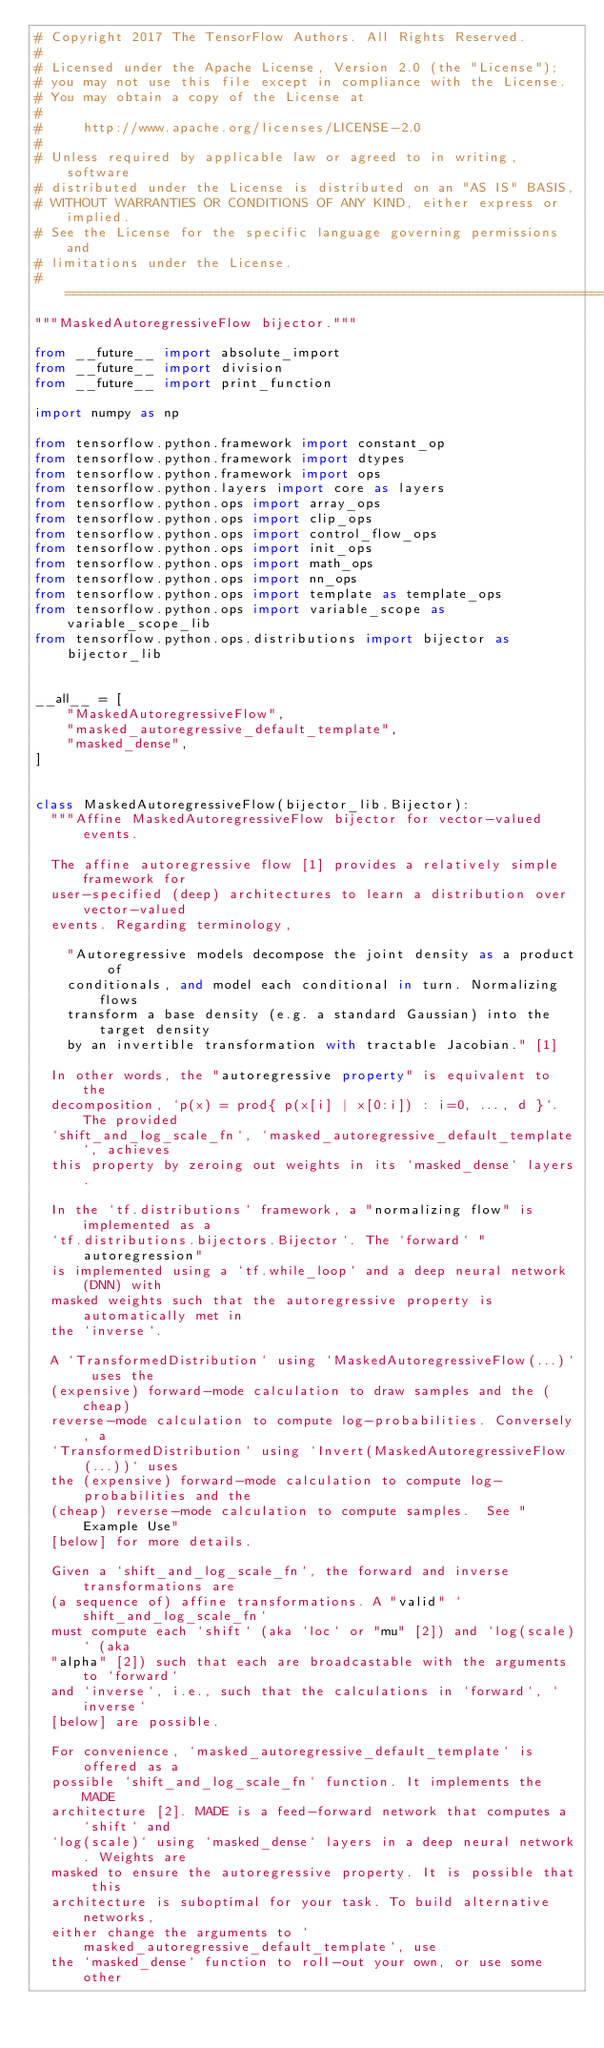Convert code to text. <code><loc_0><loc_0><loc_500><loc_500><_Python_># Copyright 2017 The TensorFlow Authors. All Rights Reserved.
#
# Licensed under the Apache License, Version 2.0 (the "License");
# you may not use this file except in compliance with the License.
# You may obtain a copy of the License at
#
#     http://www.apache.org/licenses/LICENSE-2.0
#
# Unless required by applicable law or agreed to in writing, software
# distributed under the License is distributed on an "AS IS" BASIS,
# WITHOUT WARRANTIES OR CONDITIONS OF ANY KIND, either express or implied.
# See the License for the specific language governing permissions and
# limitations under the License.
# ==============================================================================
"""MaskedAutoregressiveFlow bijector."""

from __future__ import absolute_import
from __future__ import division
from __future__ import print_function

import numpy as np

from tensorflow.python.framework import constant_op
from tensorflow.python.framework import dtypes
from tensorflow.python.framework import ops
from tensorflow.python.layers import core as layers
from tensorflow.python.ops import array_ops
from tensorflow.python.ops import clip_ops
from tensorflow.python.ops import control_flow_ops
from tensorflow.python.ops import init_ops
from tensorflow.python.ops import math_ops
from tensorflow.python.ops import nn_ops
from tensorflow.python.ops import template as template_ops
from tensorflow.python.ops import variable_scope as variable_scope_lib
from tensorflow.python.ops.distributions import bijector as bijector_lib


__all__ = [
    "MaskedAutoregressiveFlow",
    "masked_autoregressive_default_template",
    "masked_dense",
]


class MaskedAutoregressiveFlow(bijector_lib.Bijector):
  """Affine MaskedAutoregressiveFlow bijector for vector-valued events.

  The affine autoregressive flow [1] provides a relatively simple framework for
  user-specified (deep) architectures to learn a distribution over vector-valued
  events. Regarding terminology,

    "Autoregressive models decompose the joint density as a product of
    conditionals, and model each conditional in turn. Normalizing flows
    transform a base density (e.g. a standard Gaussian) into the target density
    by an invertible transformation with tractable Jacobian." [1]

  In other words, the "autoregressive property" is equivalent to the
  decomposition, `p(x) = prod{ p(x[i] | x[0:i]) : i=0, ..., d }`. The provided
  `shift_and_log_scale_fn`, `masked_autoregressive_default_template`, achieves
  this property by zeroing out weights in its `masked_dense` layers.

  In the `tf.distributions` framework, a "normalizing flow" is implemented as a
  `tf.distributions.bijectors.Bijector`. The `forward` "autoregression"
  is implemented using a `tf.while_loop` and a deep neural network (DNN) with
  masked weights such that the autoregressive property is automatically met in
  the `inverse`.

  A `TransformedDistribution` using `MaskedAutoregressiveFlow(...)` uses the
  (expensive) forward-mode calculation to draw samples and the (cheap)
  reverse-mode calculation to compute log-probabilities. Conversely, a
  `TransformedDistribution` using `Invert(MaskedAutoregressiveFlow(...))` uses
  the (expensive) forward-mode calculation to compute log-probabilities and the
  (cheap) reverse-mode calculation to compute samples.  See "Example Use"
  [below] for more details.

  Given a `shift_and_log_scale_fn`, the forward and inverse transformations are
  (a sequence of) affine transformations. A "valid" `shift_and_log_scale_fn`
  must compute each `shift` (aka `loc` or "mu" [2]) and `log(scale)` (aka
  "alpha" [2]) such that each are broadcastable with the arguments to `forward`
  and `inverse`, i.e., such that the calculations in `forward`, `inverse`
  [below] are possible.

  For convenience, `masked_autoregressive_default_template` is offered as a
  possible `shift_and_log_scale_fn` function. It implements the MADE
  architecture [2]. MADE is a feed-forward network that computes a `shift` and
  `log(scale)` using `masked_dense` layers in a deep neural network. Weights are
  masked to ensure the autoregressive property. It is possible that this
  architecture is suboptimal for your task. To build alternative networks,
  either change the arguments to `masked_autoregressive_default_template`, use
  the `masked_dense` function to roll-out your own, or use some other</code> 